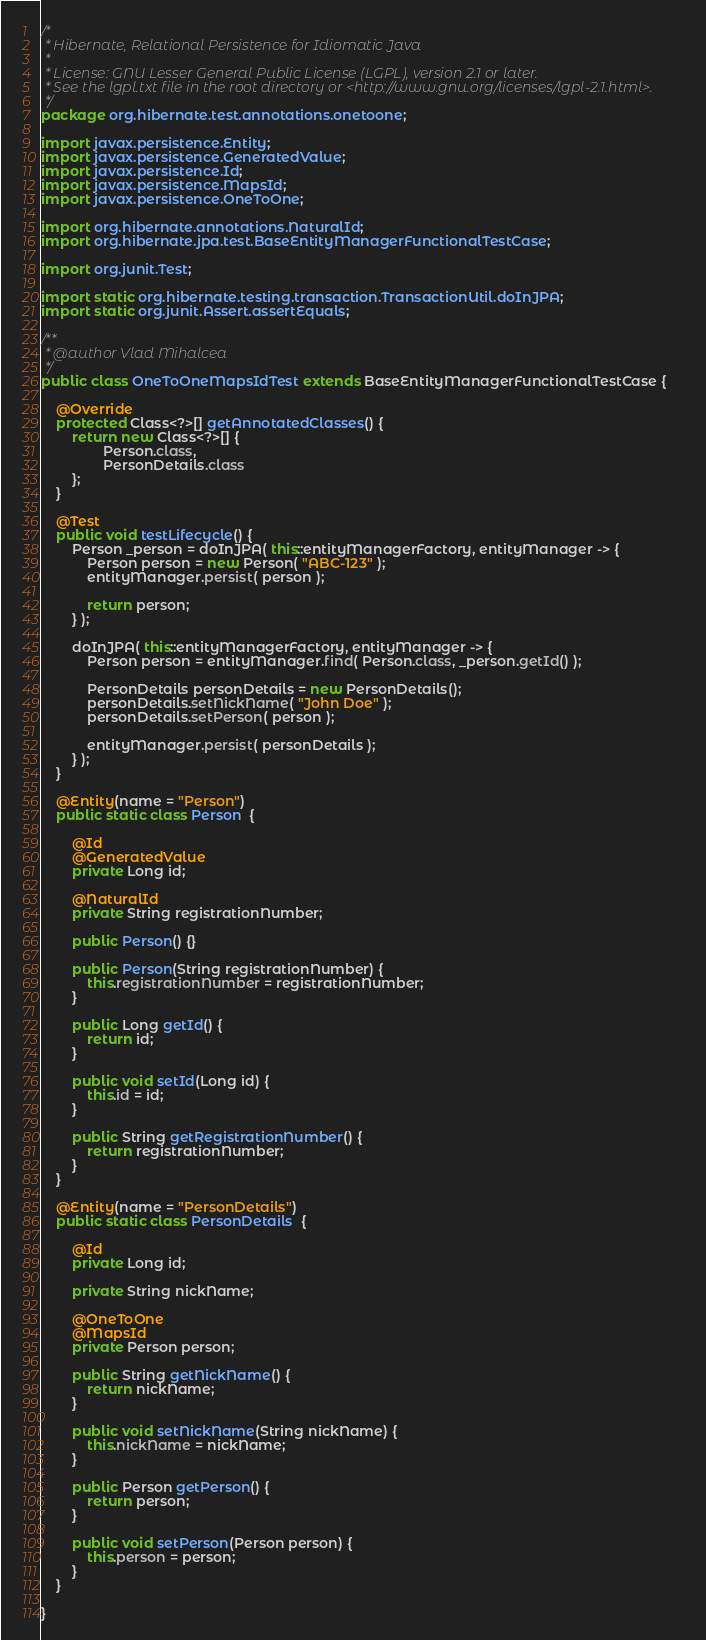Convert code to text. <code><loc_0><loc_0><loc_500><loc_500><_Java_>/*
 * Hibernate, Relational Persistence for Idiomatic Java
 *
 * License: GNU Lesser General Public License (LGPL), version 2.1 or later.
 * See the lgpl.txt file in the root directory or <http://www.gnu.org/licenses/lgpl-2.1.html>.
 */
package org.hibernate.test.annotations.onetoone;

import javax.persistence.Entity;
import javax.persistence.GeneratedValue;
import javax.persistence.Id;
import javax.persistence.MapsId;
import javax.persistence.OneToOne;

import org.hibernate.annotations.NaturalId;
import org.hibernate.jpa.test.BaseEntityManagerFunctionalTestCase;

import org.junit.Test;

import static org.hibernate.testing.transaction.TransactionUtil.doInJPA;
import static org.junit.Assert.assertEquals;

/**
 * @author Vlad Mihalcea
 */
public class OneToOneMapsIdTest extends BaseEntityManagerFunctionalTestCase {

	@Override
	protected Class<?>[] getAnnotatedClasses() {
		return new Class<?>[] {
				Person.class,
				PersonDetails.class
		};
	}

	@Test
	public void testLifecycle() {
		Person _person = doInJPA( this::entityManagerFactory, entityManager -> {
			Person person = new Person( "ABC-123" );
			entityManager.persist( person );

			return person;
		} );

		doInJPA( this::entityManagerFactory, entityManager -> {
			Person person = entityManager.find( Person.class, _person.getId() );

			PersonDetails personDetails = new PersonDetails();
			personDetails.setNickName( "John Doe" );
			personDetails.setPerson( person );

			entityManager.persist( personDetails );
		} );
	}

	@Entity(name = "Person")
	public static class Person  {

		@Id
		@GeneratedValue
		private Long id;

		@NaturalId
		private String registrationNumber;

		public Person() {}

		public Person(String registrationNumber) {
			this.registrationNumber = registrationNumber;
		}

		public Long getId() {
			return id;
		}

		public void setId(Long id) {
			this.id = id;
		}

		public String getRegistrationNumber() {
			return registrationNumber;
		}
	}

	@Entity(name = "PersonDetails")
	public static class PersonDetails  {

		@Id
		private Long id;

		private String nickName;

		@OneToOne
		@MapsId
		private Person person;

		public String getNickName() {
			return nickName;
		}

		public void setNickName(String nickName) {
			this.nickName = nickName;
		}

		public Person getPerson() {
			return person;
		}

		public void setPerson(Person person) {
			this.person = person;
		}
	}

}
</code> 